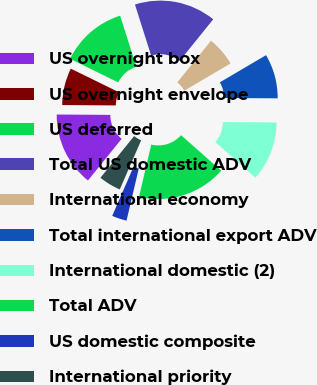<chart> <loc_0><loc_0><loc_500><loc_500><pie_chart><fcel>US overnight box<fcel>US overnight envelope<fcel>US deferred<fcel>Total US domestic ADV<fcel>International economy<fcel>Total international export ADV<fcel>International domestic (2)<fcel>Total ADV<fcel>US domestic composite<fcel>International priority<nl><fcel>14.29%<fcel>7.14%<fcel>12.86%<fcel>15.71%<fcel>5.71%<fcel>8.57%<fcel>11.43%<fcel>17.14%<fcel>2.86%<fcel>4.29%<nl></chart> 